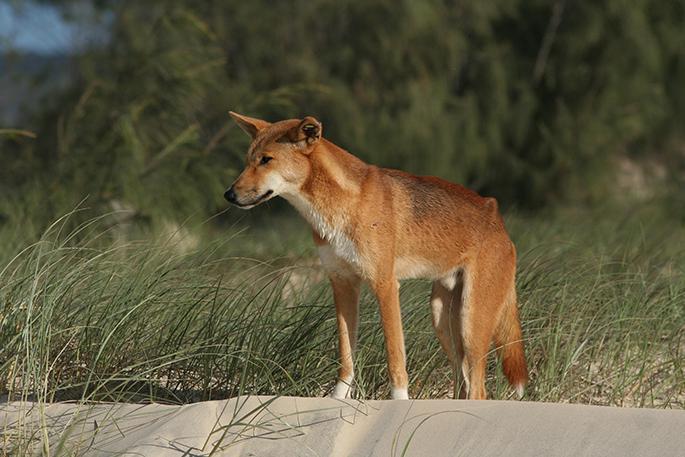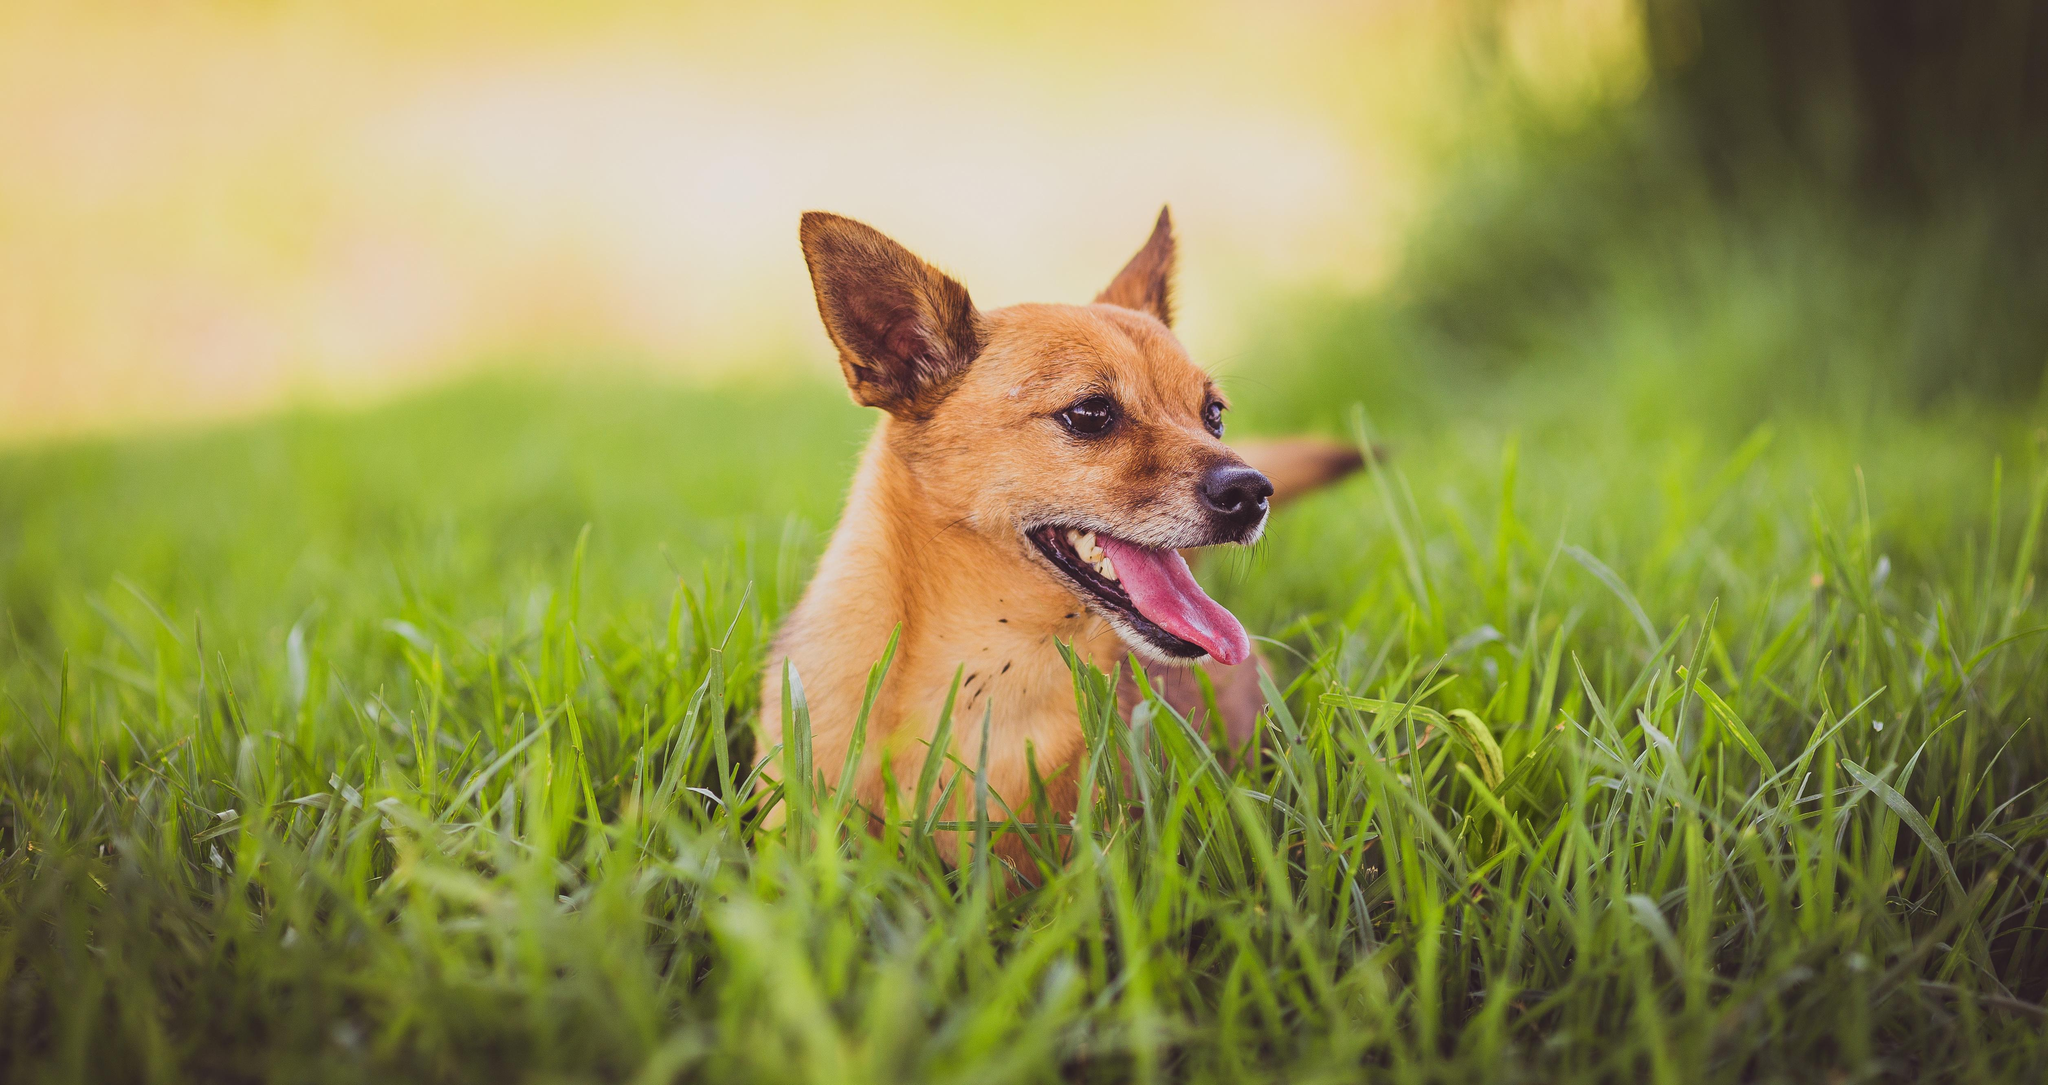The first image is the image on the left, the second image is the image on the right. Examine the images to the left and right. Is the description "There are two dogs in total." accurate? Answer yes or no. Yes. 